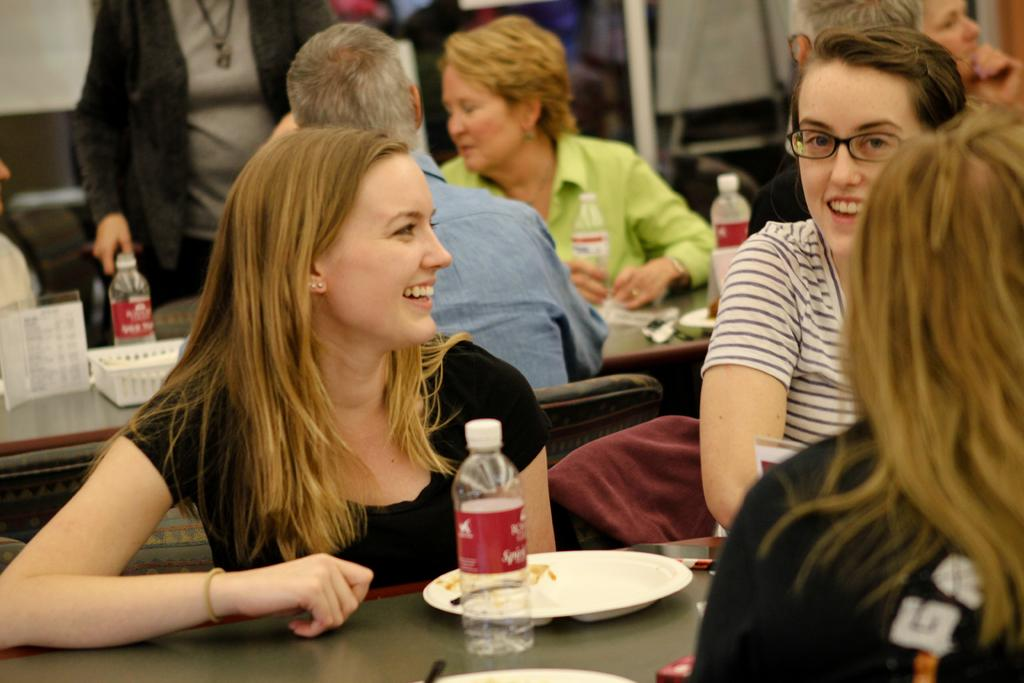How many people are in the image? There is a group of people in the image. What are the people doing in the image? The people are sitting on chairs. What objects are in front of the chairs? There are tables in front of the chairs. What can be found on the tables? The people have plates on the tables, and there is a bottle of water on the tables. What type of books can be seen on the wall in the image? There is no wall or books present in the image. 